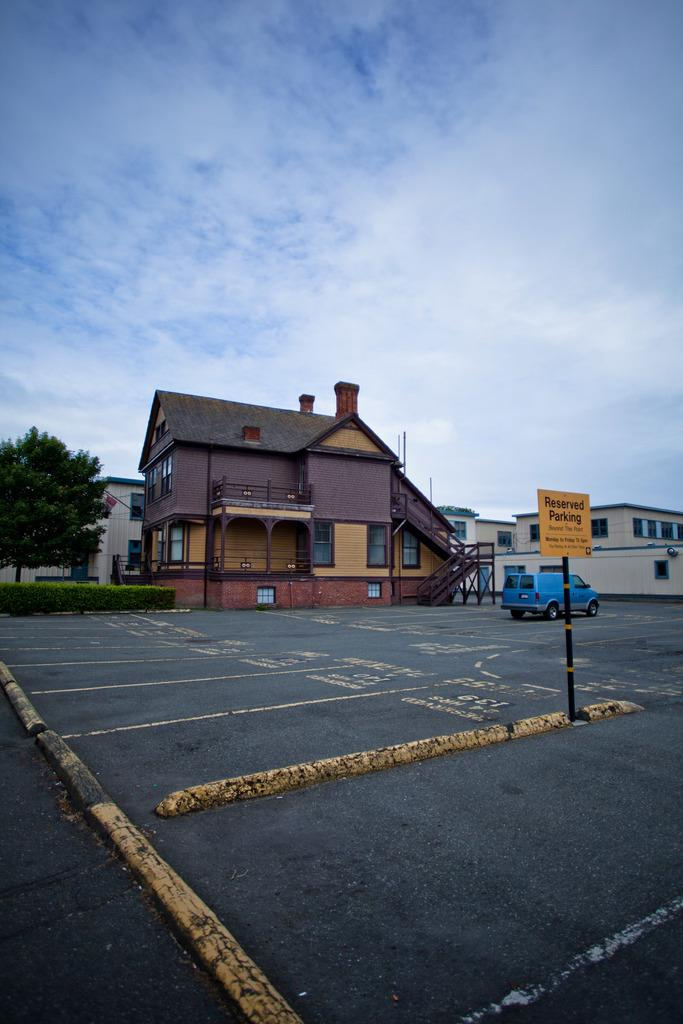What is the main feature of the image? There is a road in the image. What is happening on the road? A vehicle is present on the road. What can be seen in the distance behind the road? There are homes visible in the background. What is on the left side of the image? There is a tree on the left side of the image. What is visible above the road and the tree? The sky is visible in the image. What can be observed in the sky? Clouds are present in the sky. What type of suit is the tree wearing in the image? Trees do not wear suits, so this question is not applicable to the image. 